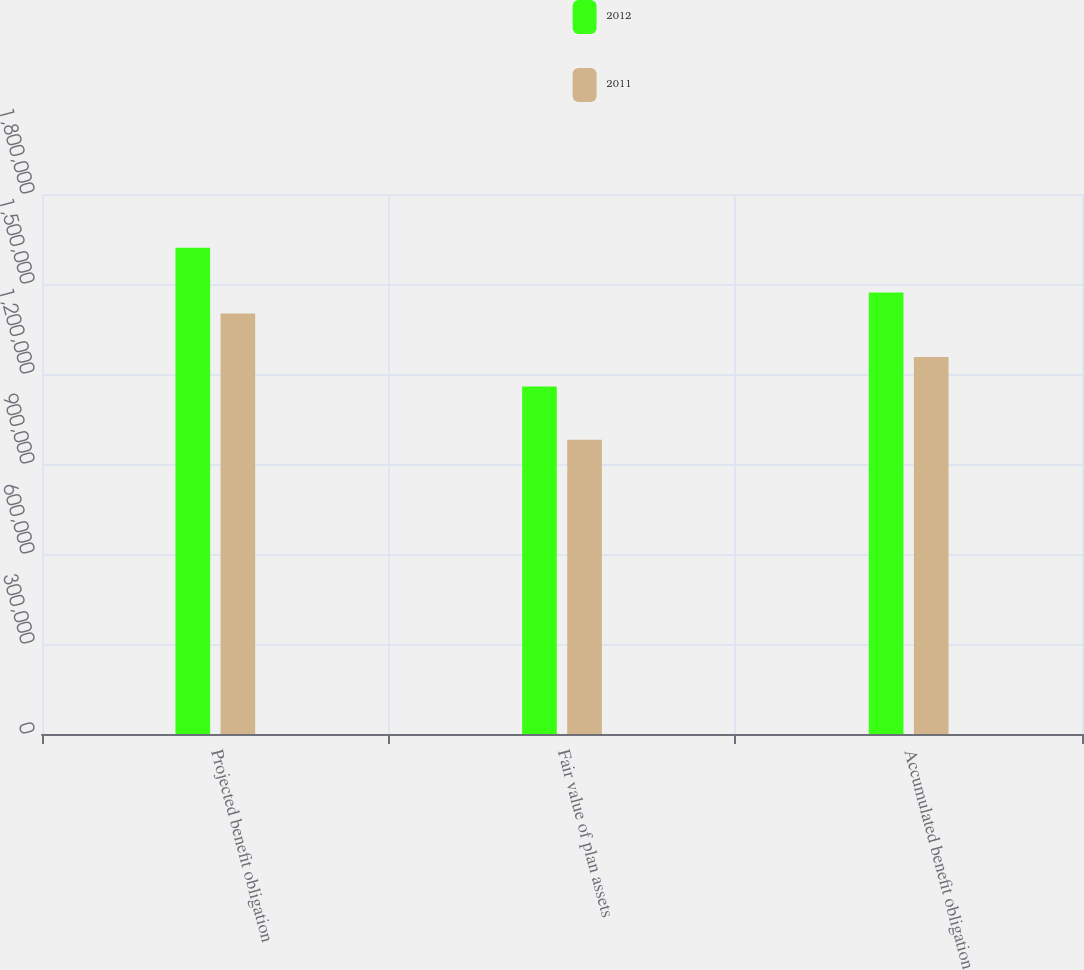Convert chart to OTSL. <chart><loc_0><loc_0><loc_500><loc_500><stacked_bar_chart><ecel><fcel>Projected benefit obligation<fcel>Fair value of plan assets<fcel>Accumulated benefit obligation<nl><fcel>2012<fcel>1.621e+06<fcel>1.158e+06<fcel>1.472e+06<nl><fcel>2011<fcel>1.402e+06<fcel>981000<fcel>1.257e+06<nl></chart> 